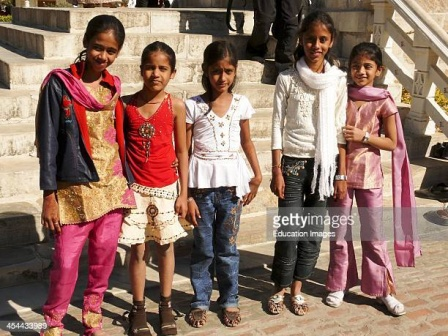What do you notice about the significance of each girl's clothing in this picture? The clothing of each girl in the image seems to reflect a blend of personal style and cultural influence. The use of traditional garments alongside more contemporary outfits indicates a celebration of heritage and individuality. The pink and gold outfits on the two girls at the ends point to a coordinated effort, perhaps indicating a shared tradition or familial bond. The vibrant red and gold outfit stands out in the middle, while the more casual attire of jeans and white tops on the other two girls adds a modern twist. This juxtaposition beautifully captures the fusion of traditional and contemporary fashion, highlighting the rich tapestry of culture and personal expression. Can you describe what each girl might be thinking or feeling in this scene? The girl on the far left, with her bright smile, seems genuinely happy and perhaps excited about the occasion. The second girl, in red and gold, has a more neutral expression, which might suggest she is feeling calm, or perhaps she's deep in thought about the events unfolding around her. The middle girl, dressed in a white blouse and jeans, appears relaxed and comfortable, possibly enjoying the company of her friends. The fourth girl, with her distinctive white scarf, carries an air of grace and elegance, perhaps feeling proud of her appearance. The girl on the far right, sharing a similar outfit with the first, displays a content and celebratory demeanor, hinting at a sense of joy and camaraderie shared among the group. 